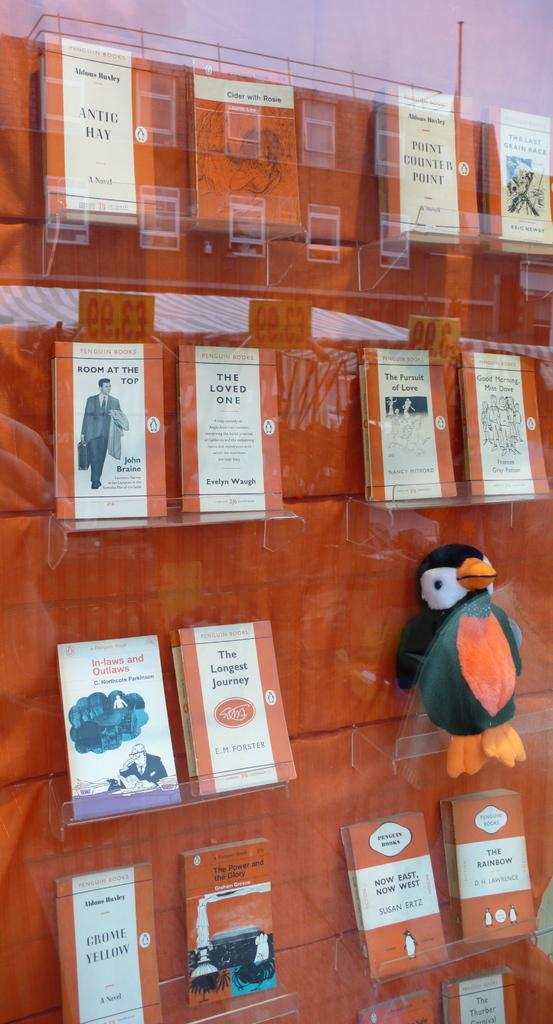<image>
Render a clear and concise summary of the photo. A scene at a bookstore with a wooden wall featuring several book including one called The Loved One. 